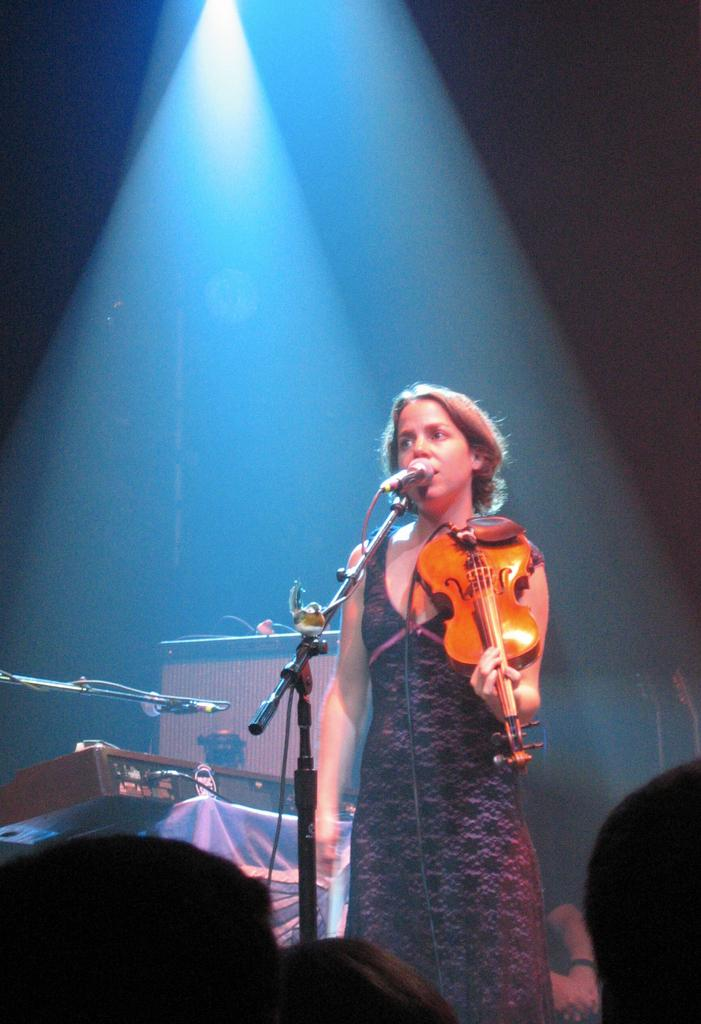Who is the main subject in the image? There is a girl in the image. What is the girl doing in the image? The girl is playing a violin and singing on a mic. Are there any other music instruments in the image? Yes, there are other music instruments in the image. How is the girl's performance being highlighted in the image? The light is focused on the top of the girl. What type of animal is playing the violin with the girl in the image? There is no animal present in the image; the girl is playing the violin by herself. What kind of glue is being used to hold the violin together in the image? There is no glue visible in the image, and the violin appears to be intact and functioning properly. 